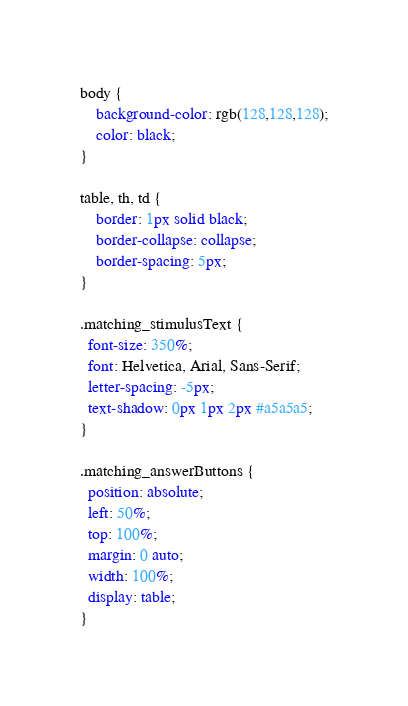<code> <loc_0><loc_0><loc_500><loc_500><_CSS_>body {
    background-color: rgb(128,128,128);
	color: black;
}

table, th, td {
    border: 1px solid black;
    border-collapse: collapse;
	border-spacing: 5px;
}

.matching_stimulusText {
  font-size: 350%;
  font: Helvetica, Arial, Sans-Serif; 
  letter-spacing: -5px;  
  text-shadow: 0px 1px 2px #a5a5a5;
}

.matching_answerButtons {
  position: absolute;
  left: 50%;
  top: 100%;
  margin: 0 auto;
  width: 100%;
  display: table;
}</code> 